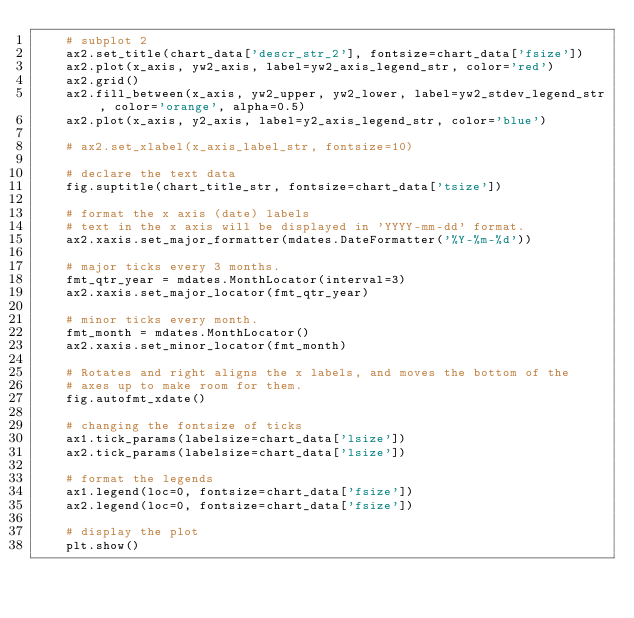<code> <loc_0><loc_0><loc_500><loc_500><_Python_>    # subplot 2
    ax2.set_title(chart_data['descr_str_2'], fontsize=chart_data['fsize'])
    ax2.plot(x_axis, yw2_axis, label=yw2_axis_legend_str, color='red')
    ax2.grid()
    ax2.fill_between(x_axis, yw2_upper, yw2_lower, label=yw2_stdev_legend_str, color='orange', alpha=0.5)
    ax2.plot(x_axis, y2_axis, label=y2_axis_legend_str, color='blue')

    # ax2.set_xlabel(x_axis_label_str, fontsize=10)

    # declare the text data
    fig.suptitle(chart_title_str, fontsize=chart_data['tsize'])

    # format the x axis (date) labels
    # text in the x axis will be displayed in 'YYYY-mm-dd' format.
    ax2.xaxis.set_major_formatter(mdates.DateFormatter('%Y-%m-%d'))

    # major ticks every 3 months.
    fmt_qtr_year = mdates.MonthLocator(interval=3)
    ax2.xaxis.set_major_locator(fmt_qtr_year)

    # minor ticks every month.
    fmt_month = mdates.MonthLocator()
    ax2.xaxis.set_minor_locator(fmt_month)

    # Rotates and right aligns the x labels, and moves the bottom of the
    # axes up to make room for them.
    fig.autofmt_xdate()

    # changing the fontsize of ticks
    ax1.tick_params(labelsize=chart_data['lsize'])
    ax2.tick_params(labelsize=chart_data['lsize'])

    # format the legends
    ax1.legend(loc=0, fontsize=chart_data['fsize'])
    ax2.legend(loc=0, fontsize=chart_data['fsize'])

    # display the plot
    plt.show()
</code> 